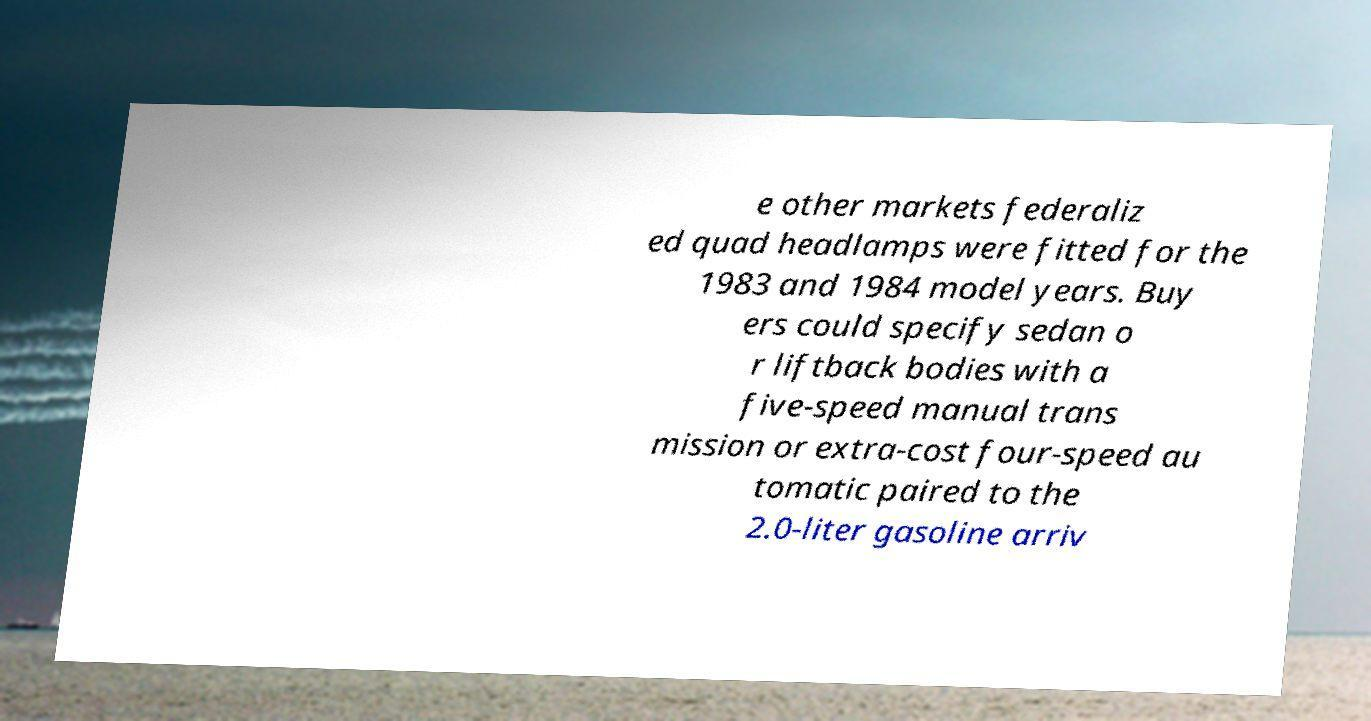I need the written content from this picture converted into text. Can you do that? e other markets federaliz ed quad headlamps were fitted for the 1983 and 1984 model years. Buy ers could specify sedan o r liftback bodies with a five-speed manual trans mission or extra-cost four-speed au tomatic paired to the 2.0-liter gasoline arriv 